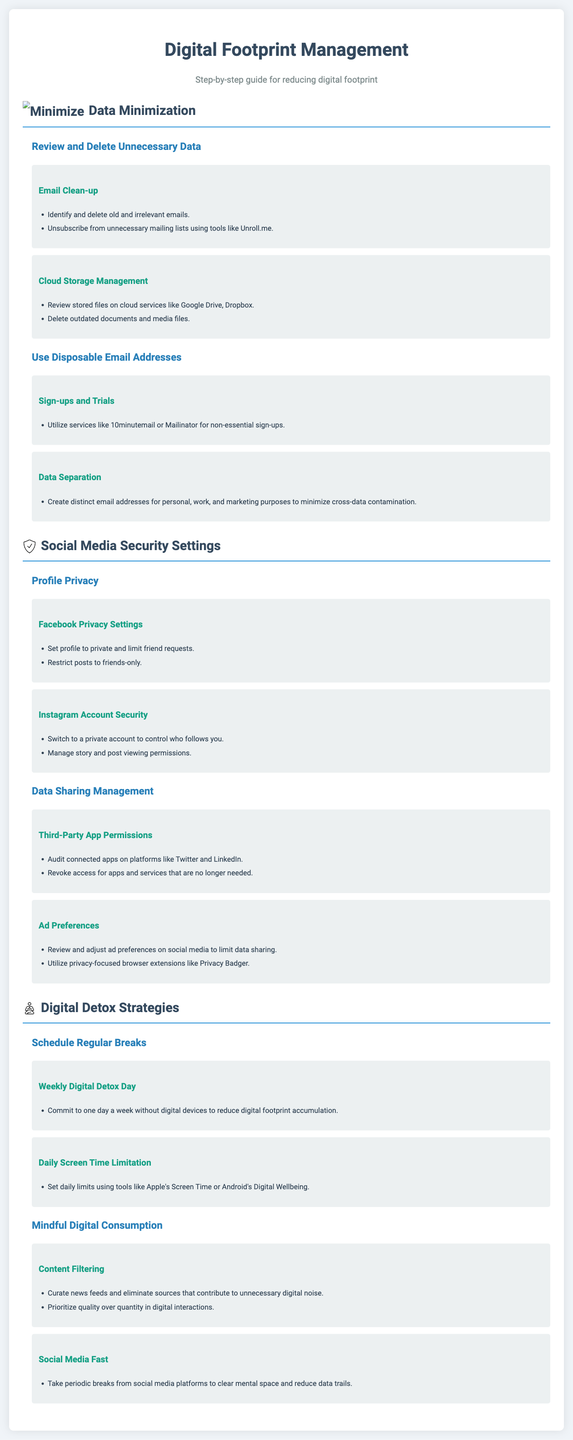What are the two main sections listed under Digital Detox Strategies? The two main sections are "Schedule Regular Breaks" and "Mindful Digital Consumption."
Answer: Schedule Regular Breaks, Mindful Digital Consumption Which tool is suggested for limiting daily screen time? The document suggests using Apple's Screen Time or Android's Digital Wellbeing.
Answer: Apple's Screen Time or Android's Digital Wellbeing What service can be used to unsubscribe from mailing lists? The document mentions Unroll.me as a tool for unsubscribing from mailing lists.
Answer: Unroll.me How many activities are listed under Profile Privacy? There are two activities listed under Profile Privacy.
Answer: 2 What is the purpose of the "Social Media Fast" activity? The activity is aimed at taking periodic breaks from social media platforms to clear mental space and reduce data trails.
Answer: Reduce data trails What should you do with connected apps on social media platforms according to the document? You should audit connected apps and revoke access for apps no longer needed.
Answer: Audit and revoke access What is the recommended action for managing cloud storage? The document recommends reviewing stored files and deleting outdated documents and media files.
Answer: Review and delete outdated documents How often should digital detox days be scheduled? The recommendation is to commit to one day a week without digital devices.
Answer: One day a week 